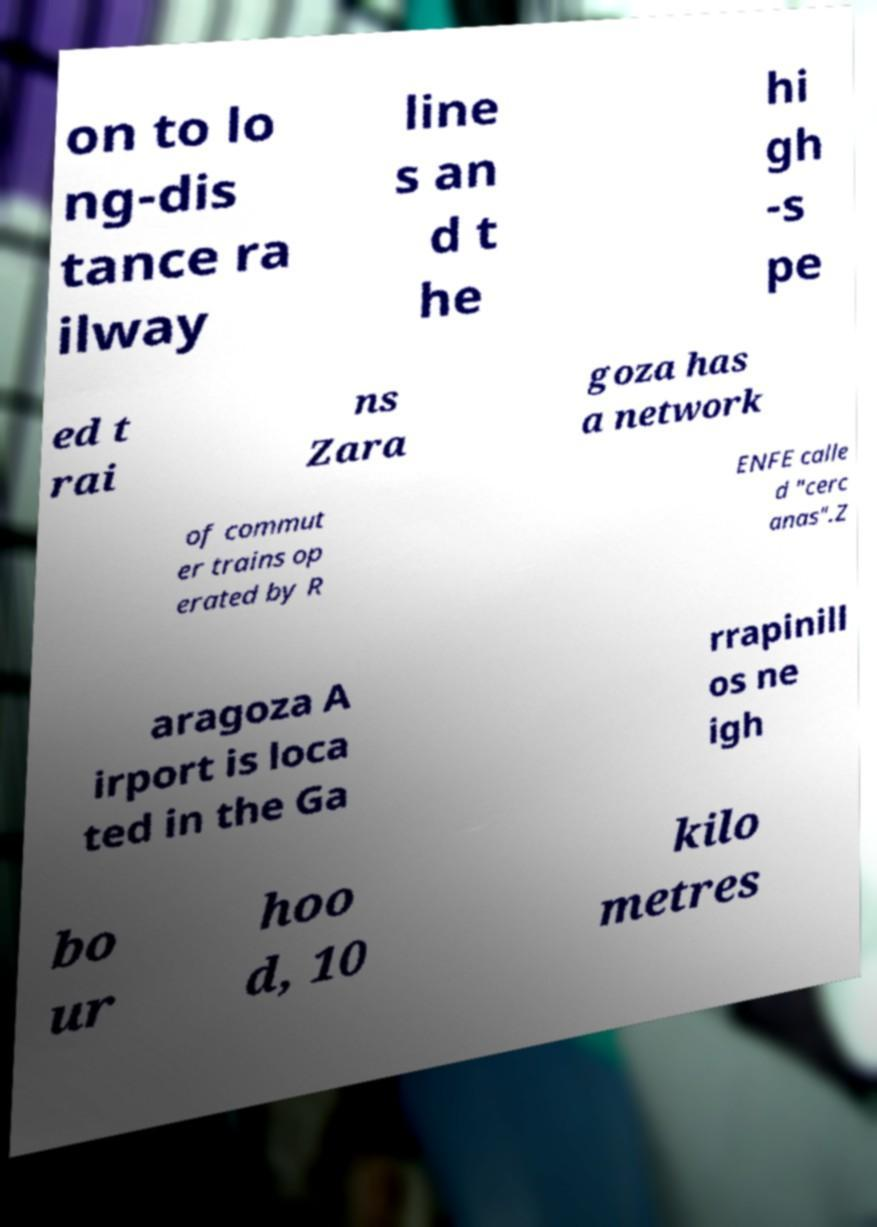There's text embedded in this image that I need extracted. Can you transcribe it verbatim? on to lo ng-dis tance ra ilway line s an d t he hi gh -s pe ed t rai ns Zara goza has a network of commut er trains op erated by R ENFE calle d "cerc anas".Z aragoza A irport is loca ted in the Ga rrapinill os ne igh bo ur hoo d, 10 kilo metres 